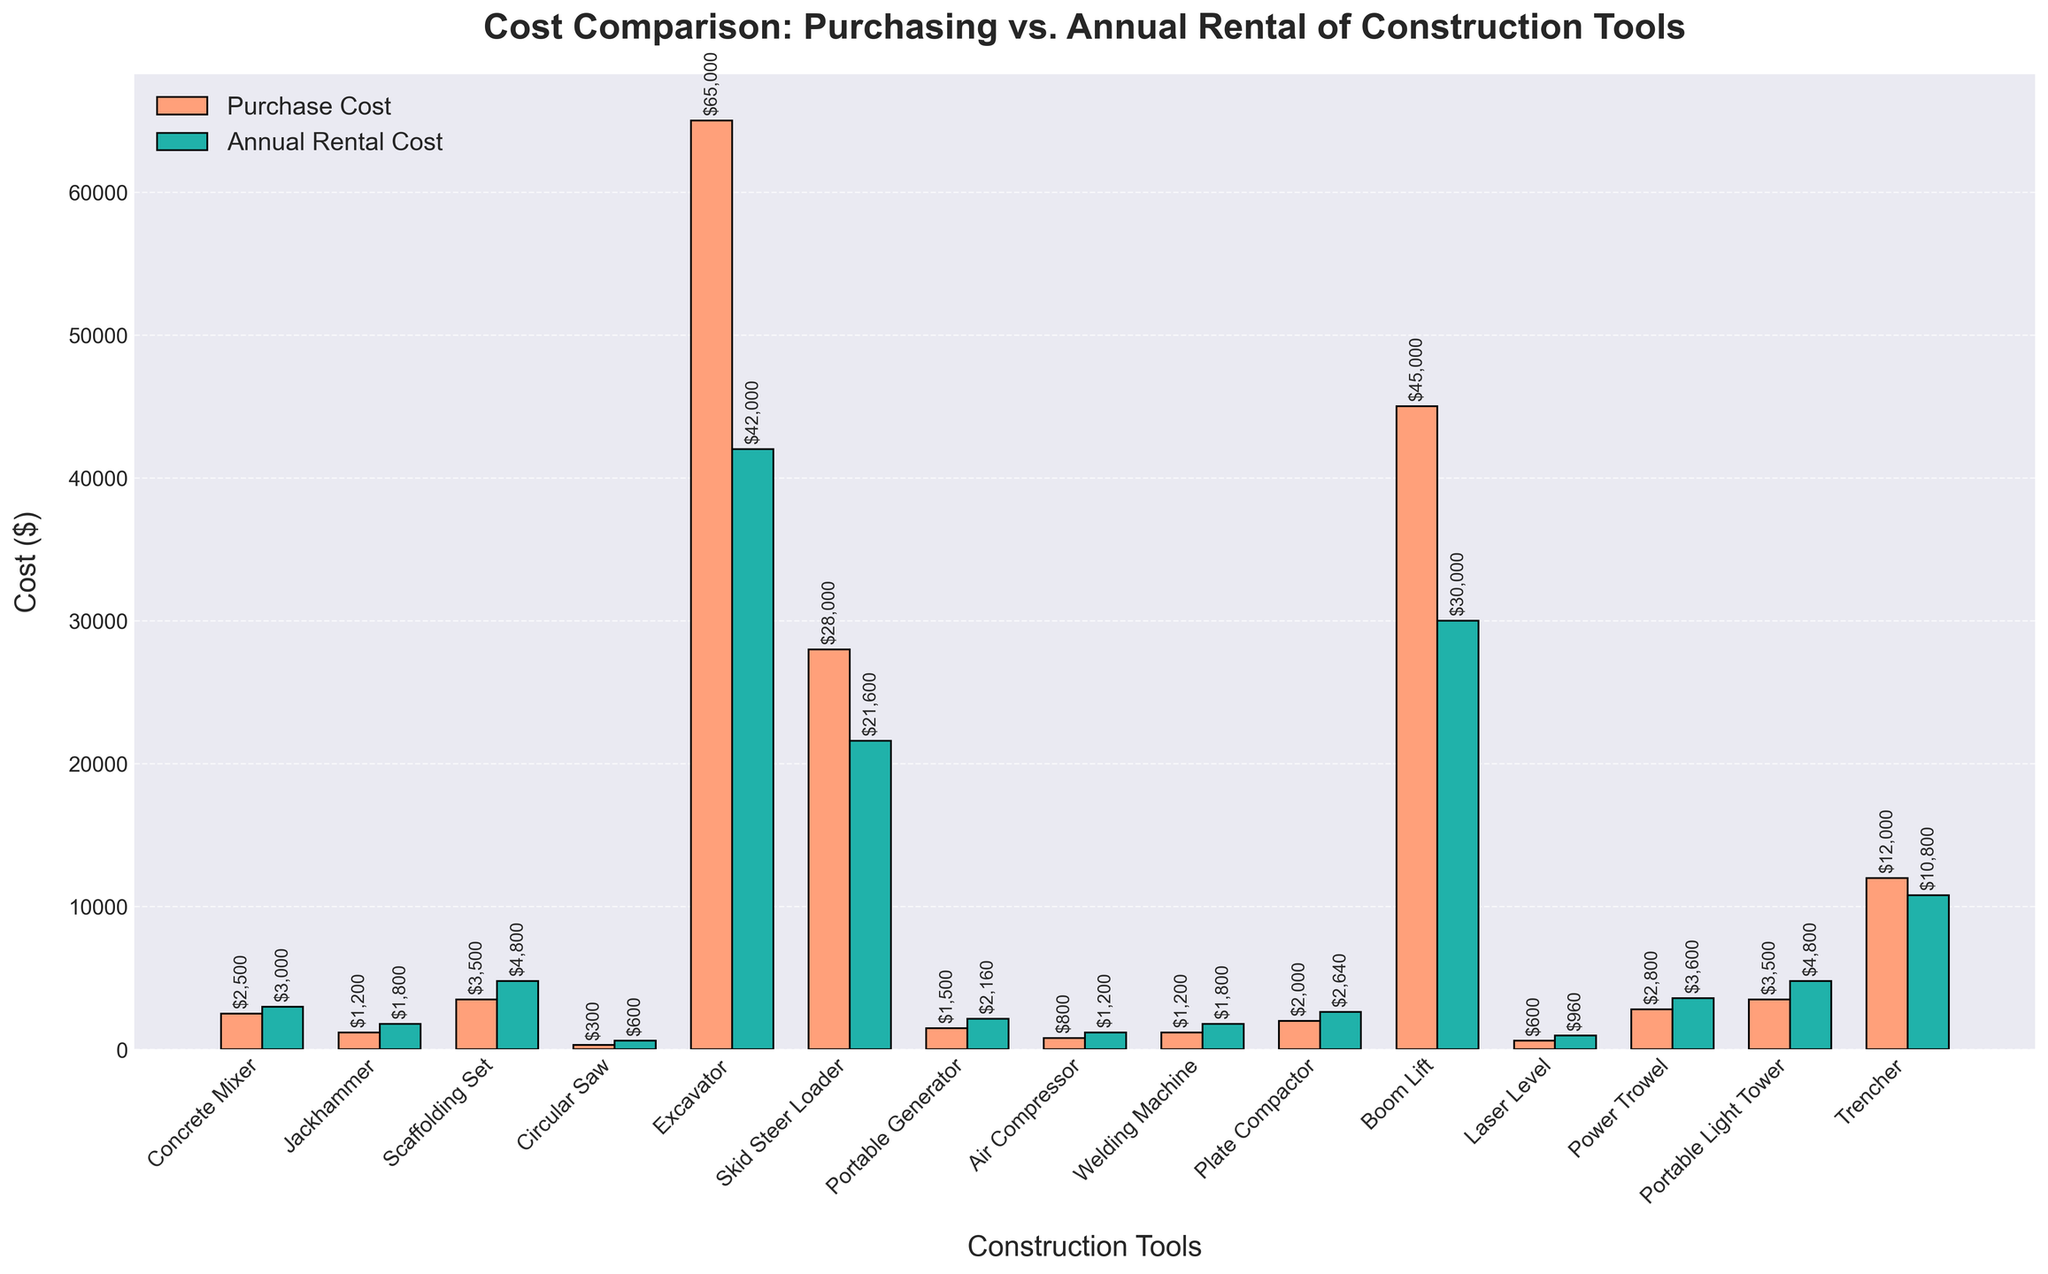What's the total purchase cost of the Concrete Mixer, Jackhammer, and Scaffolding Set? The purchase cost of the Concrete Mixer is $2500, Jackhammer is $1200, and Scaffolding Set is $3500. The total is 2500 + 1200 + 3500 = 7200
Answer: 7200 Which tool is the least expensive to rent annually when compared to its purchase cost? The Portable Generator is rented at $180 per month, making its annual rental cost $180 × 12 = $2160, against a purchase cost of $1500. All other tools' annual rental costs are greater than their purchase costs.
Answer: Portable Generator What is the difference in cost between purchasing and renting annually the Excavator? The purchase cost of the Excavator is $65000, and the annual rental cost is $3500 × 12 = $42000. The difference is $65000 - $42000 = $23000
Answer: 23000 How many tools have a higher purchase cost than their annual rental cost? Count the tools where the purchase cost bar is taller than the annual rental cost bar. These are Concrete Mixer, Circular Saw, Power Trowel, Portable Generator, and Plate Compactor.
Answer: 5 What is the average annual rental cost of Laser Level, Power Trowel, and Portable Light Tower? The monthly rental costs of Laser Level, Power Trowel, and Portable Light Tower are $80, $300, and $400 respectively. Their annual rental costs are ($80 × 12 = $960), ($300 × 12 = $3600), ($400 × 12 = $4800). The average is (960 + 3600 + 4800) / 3 = 3120
Answer: 3120 Which tool has the highest purchase cost, and what is it? By inspecting the bar heights, the Excavator has the highest purchase cost. The label indicates a $65000 cost.
Answer: Excavator, $65000 Is the welding machine more expensive to purchase or to rent annually? The purchase cost of the Welding Machine is $1200 while the annual rental cost is $150 × 12 = $1800. Since 1800 > 1200, it is more expensive to rent annually.
Answer: More expensive to rent annually Does the Boom Lift have a higher purchase cost or annual rental cost? The purchase cost of the Boom Lift is $45000, while the annual rental cost is $2500 × 12 = $30000. Since 45000 > 30000, it has a higher purchase cost.
Answer: Higher purchase cost 